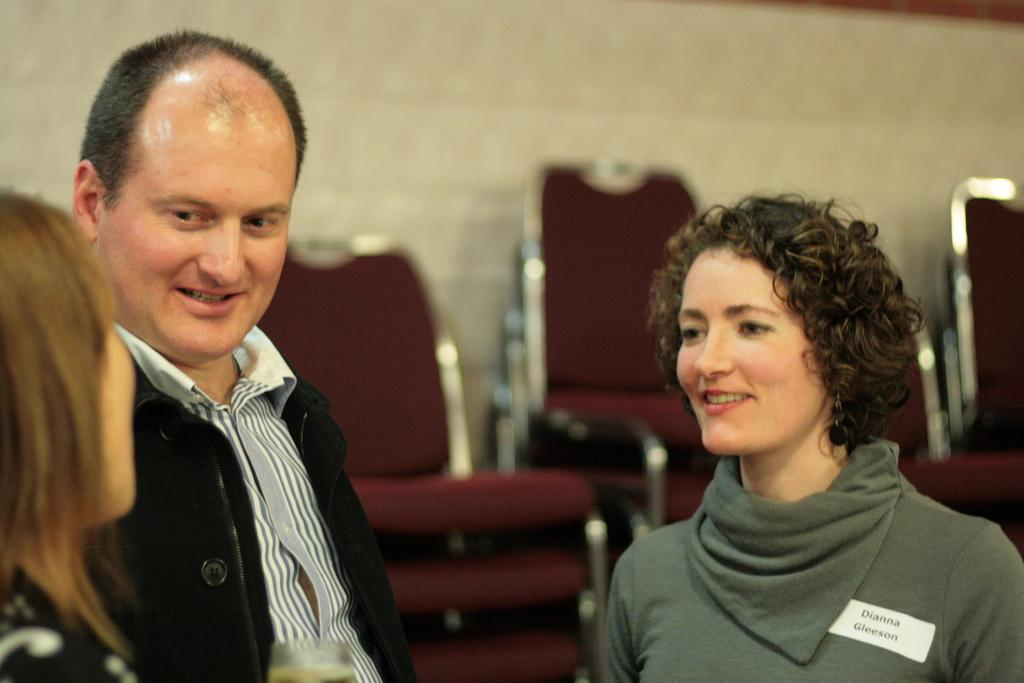How many people are in the image? There are three people in the image. What is the facial expression of the people in the image? Two of the people are smiling. What can be seen in the background of the image? There are chairs and a wall visible in the background of the image. What hobbies do the people in the image have? There is no information about the hobbies of the people in the image. Is there a basketball game happening in the image? There is no basketball game or any reference to basketball in the image. 